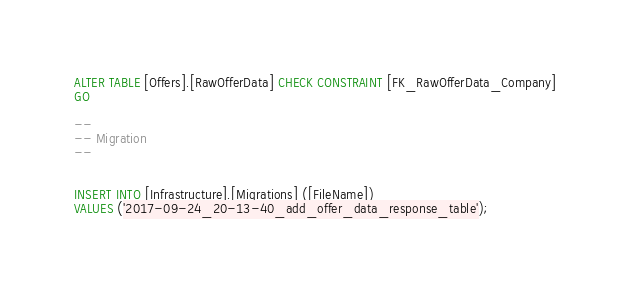<code> <loc_0><loc_0><loc_500><loc_500><_SQL_>
ALTER TABLE [Offers].[RawOfferData] CHECK CONSTRAINT [FK_RawOfferData_Company]
GO

--
-- Migration
--


INSERT INTO [Infrastructure].[Migrations] ([FileName]) 
VALUES ('2017-09-24_20-13-40_add_offer_data_response_table');</code> 